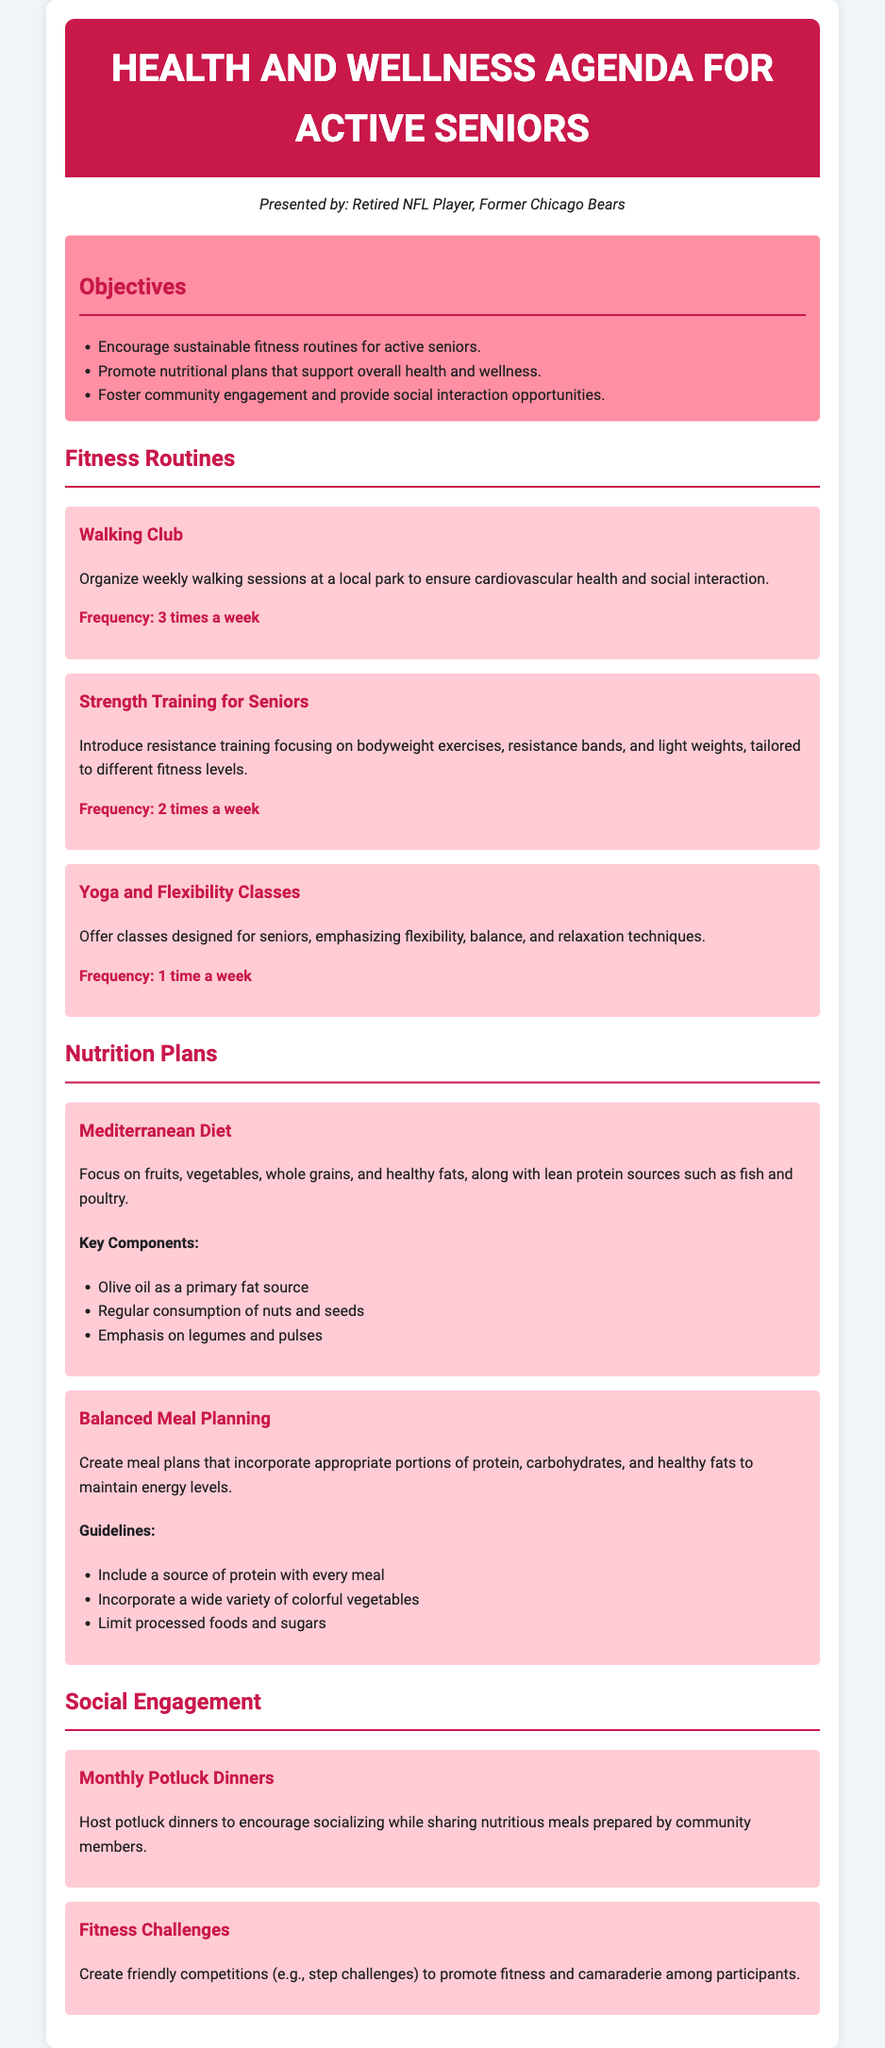What is the title of the document? The title is stated clearly at the top of the agenda document.
Answer: Health and Wellness Agenda for Active Seniors How often does the Walking Club meet? The frequency of the Walking Club is mentioned in its specific section.
Answer: 3 times a week What is the primary fat source in the Mediterranean Diet? The document outlines key components of the Mediterranean Diet emphasizing its primary fat source.
Answer: Olive oil What activity is designed to promote fitness and camaraderie? This is mentioned under social engagement, and it refers to friendly competitions.
Answer: Fitness Challenges How many times a week is Yoga offered? The frequency of Yoga and Flexibility Classes is detailed in the fitness routines section.
Answer: 1 time a week What type of meals are encouraged at the Monthly Potluck Dinners? The activity description defines the nature of the meals shared at these dinners.
Answer: Nutritious meals What are two components of the Balanced Meal Planning guidelines? The guidelines provide multiple recommendations, two of which can be specifically referenced.
Answer: Include a source of protein with every meal; Incorporate a wide variety of colorful vegetables Which fitness routine involves resistance training? The fitness routines section discusses various routines and specifies the focus of one.
Answer: Strength Training for Seniors 